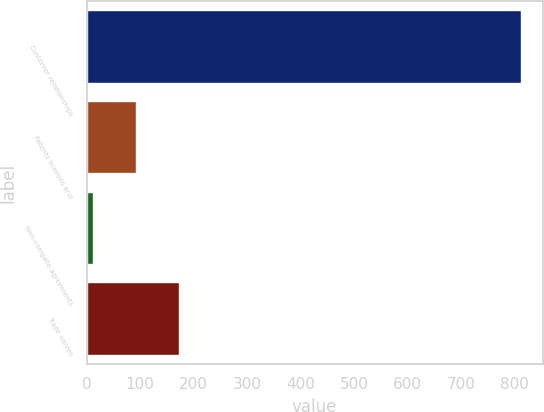Convert chart. <chart><loc_0><loc_0><loc_500><loc_500><bar_chart><fcel>Customer relationships<fcel>Patents licenses and<fcel>Non-compete agreements<fcel>Trade names<nl><fcel>812.8<fcel>92.71<fcel>12.7<fcel>172.72<nl></chart> 